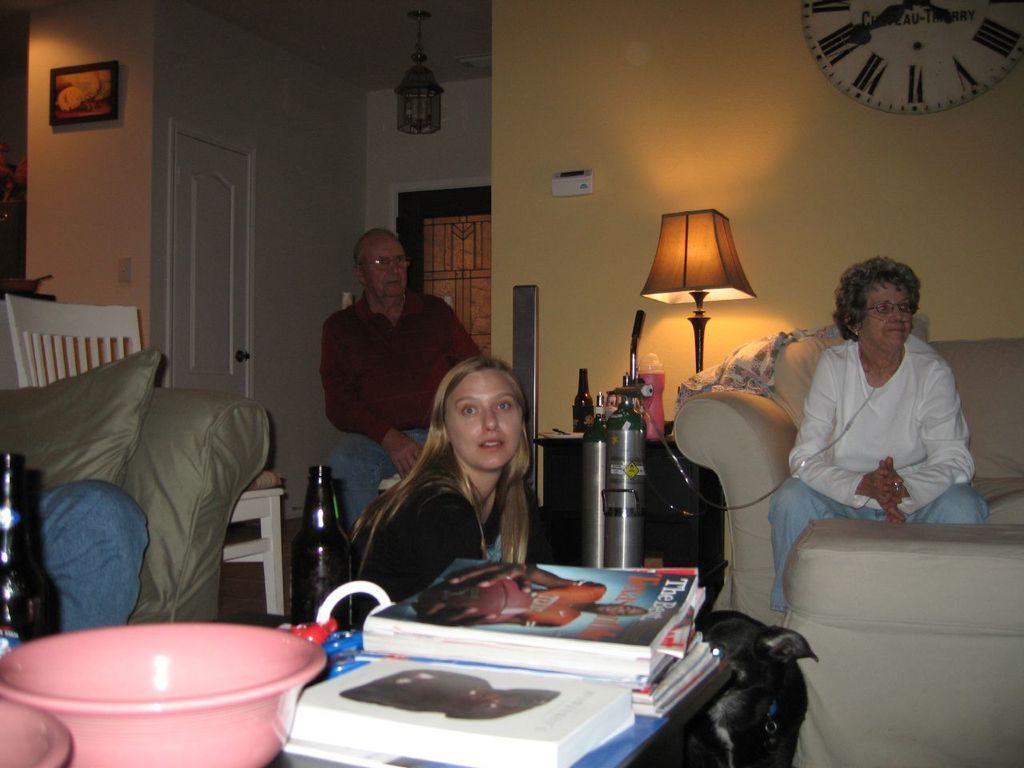How would you summarize this image in a sentence or two? This is the picture in a room, there are three people sitting. The women in white t shirt sitting on the couch and the black dress girl sitting on the floor and the man in red shirt sitting on the chair. This is a table on the table there are the books and beside the table there is a black color dog. Beside the white color t shirt women there is table on the table there is a lamp backside of the lamp there is yellow color wall on the wall there is wall clock. On the roof there is a chandelier and white color door beside the man. On the table there are the bottles. 